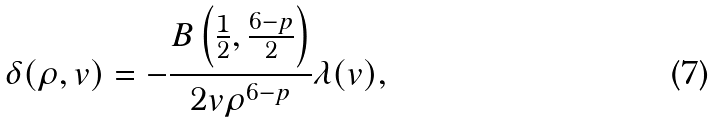Convert formula to latex. <formula><loc_0><loc_0><loc_500><loc_500>\delta ( \rho , v ) = - \frac { B \left ( \frac { 1 } { 2 } , \frac { 6 - p } { 2 } \right ) } { 2 v \rho ^ { 6 - p } } \lambda ( v ) ,</formula> 